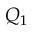Convert formula to latex. <formula><loc_0><loc_0><loc_500><loc_500>Q _ { 1 }</formula> 